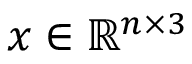<formula> <loc_0><loc_0><loc_500><loc_500>x \in \mathbb { R } ^ { n \times 3 }</formula> 